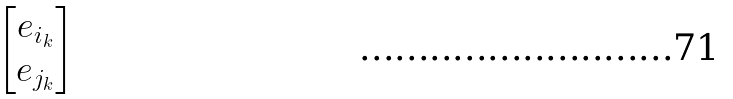Convert formula to latex. <formula><loc_0><loc_0><loc_500><loc_500>\begin{bmatrix} e _ { i _ { k } } \\ e _ { j _ { k } } \end{bmatrix}</formula> 